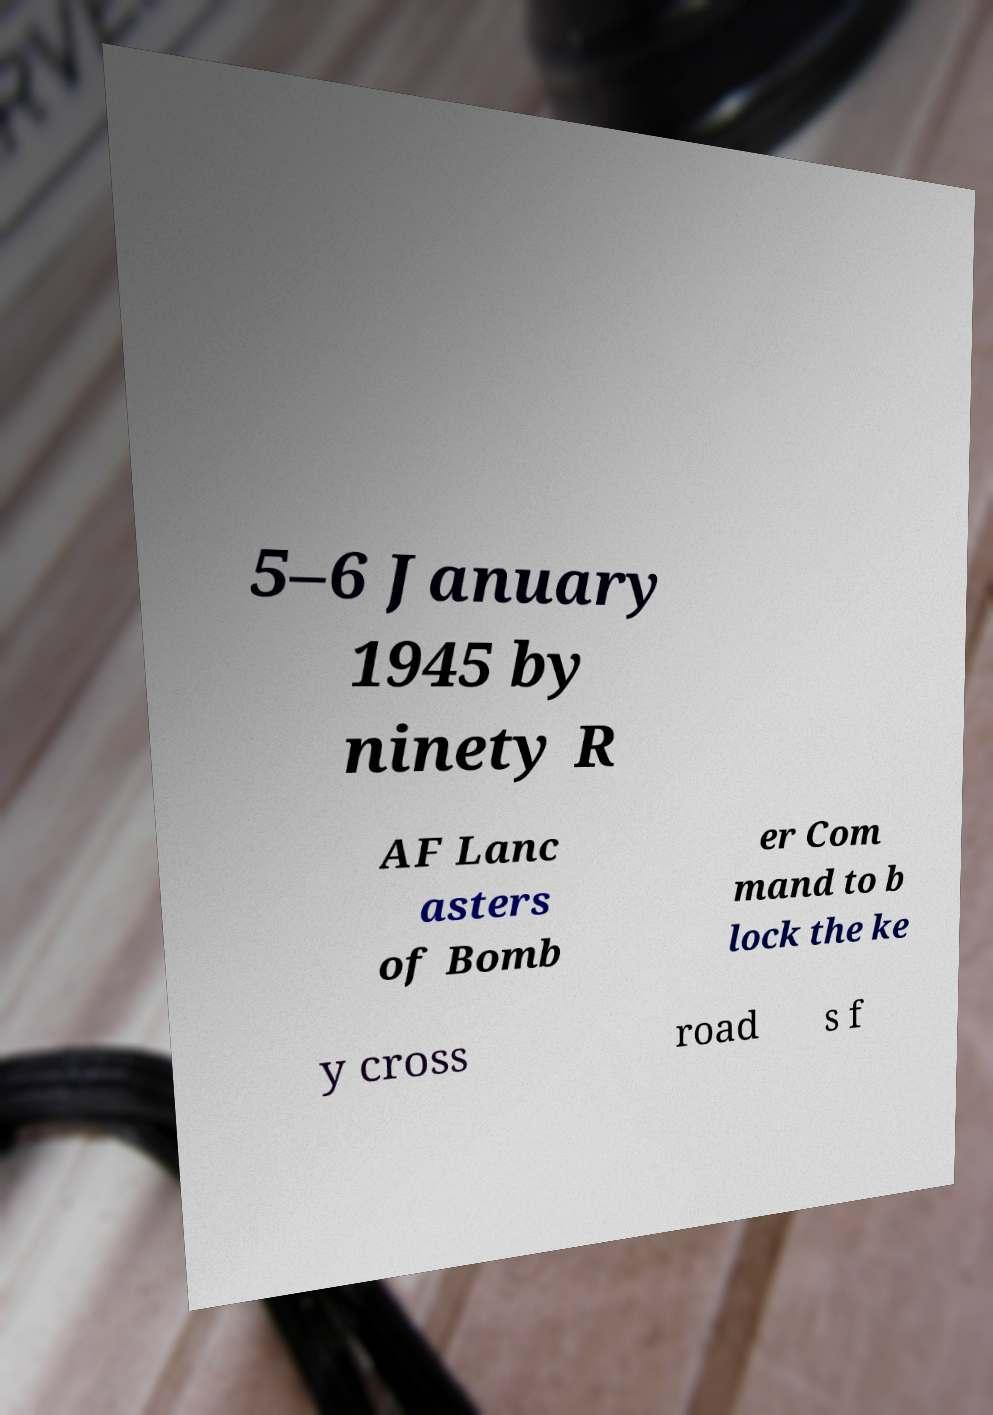Can you accurately transcribe the text from the provided image for me? 5–6 January 1945 by ninety R AF Lanc asters of Bomb er Com mand to b lock the ke y cross road s f 